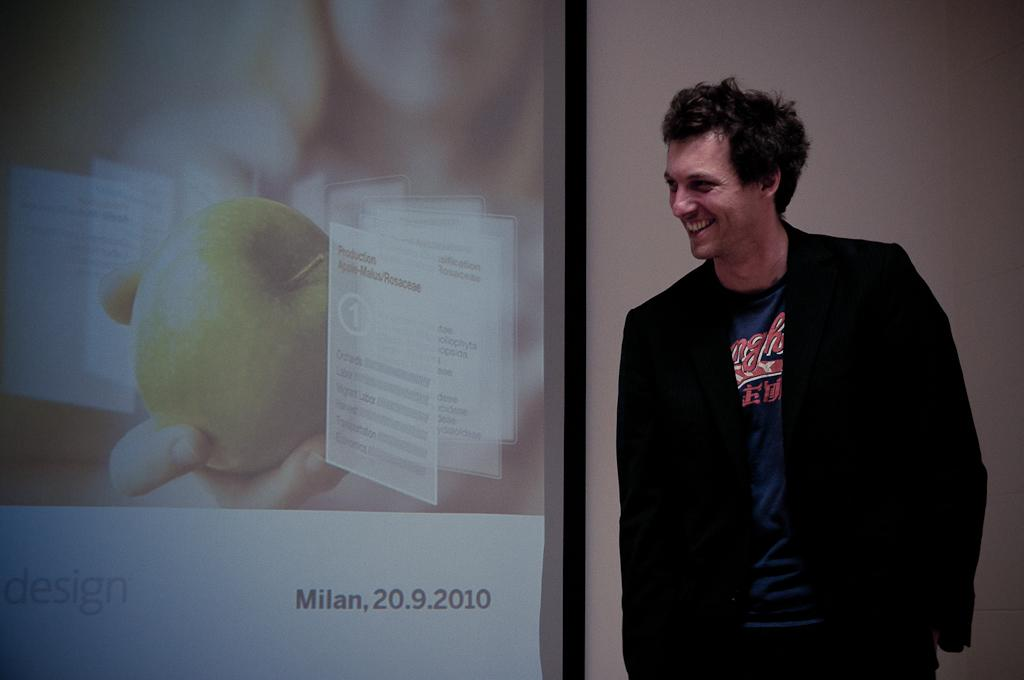<image>
Provide a brief description of the given image. A man is smiling next to a picture from Milan in 2010. 